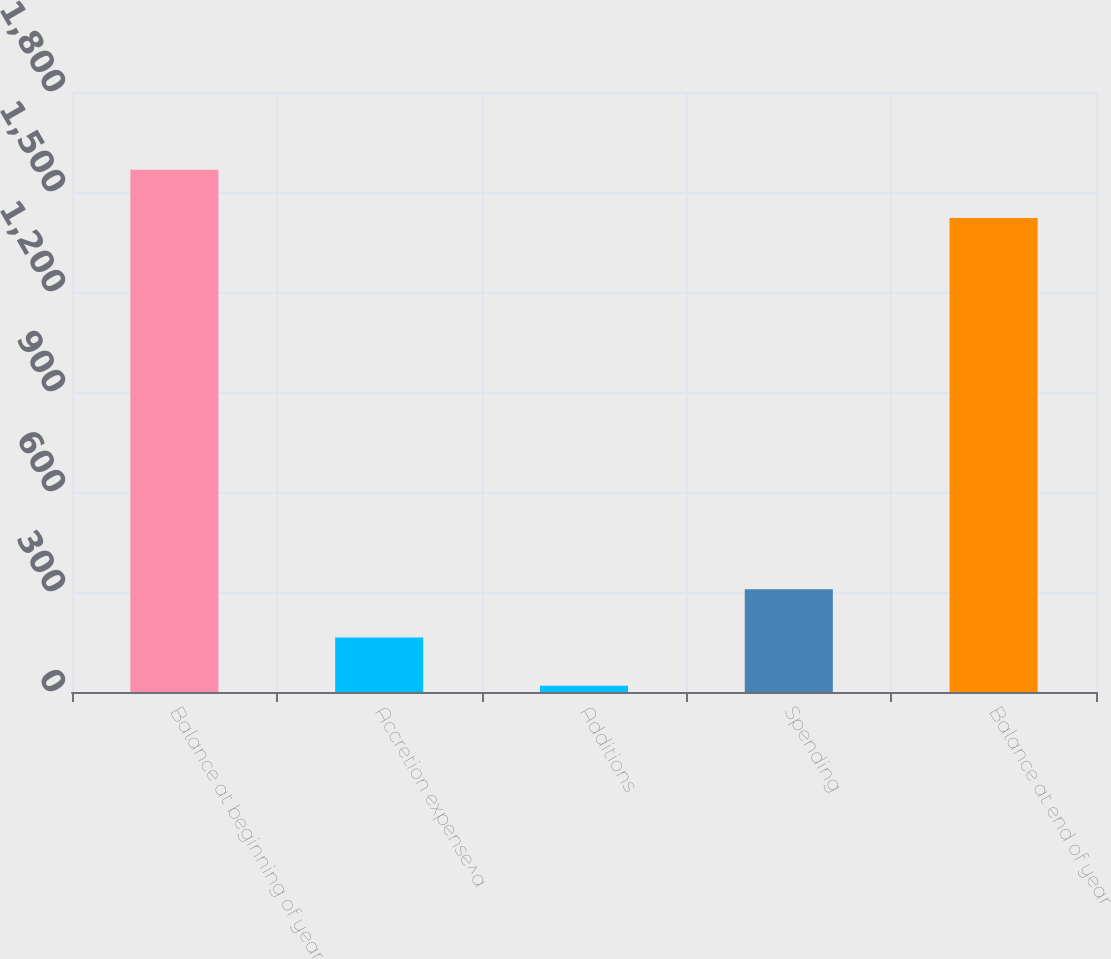Convert chart to OTSL. <chart><loc_0><loc_0><loc_500><loc_500><bar_chart><fcel>Balance at beginning of year<fcel>Accretion expense^a<fcel>Additions<fcel>Spending<fcel>Balance at end of year<nl><fcel>1566.5<fcel>163.5<fcel>19<fcel>308<fcel>1422<nl></chart> 